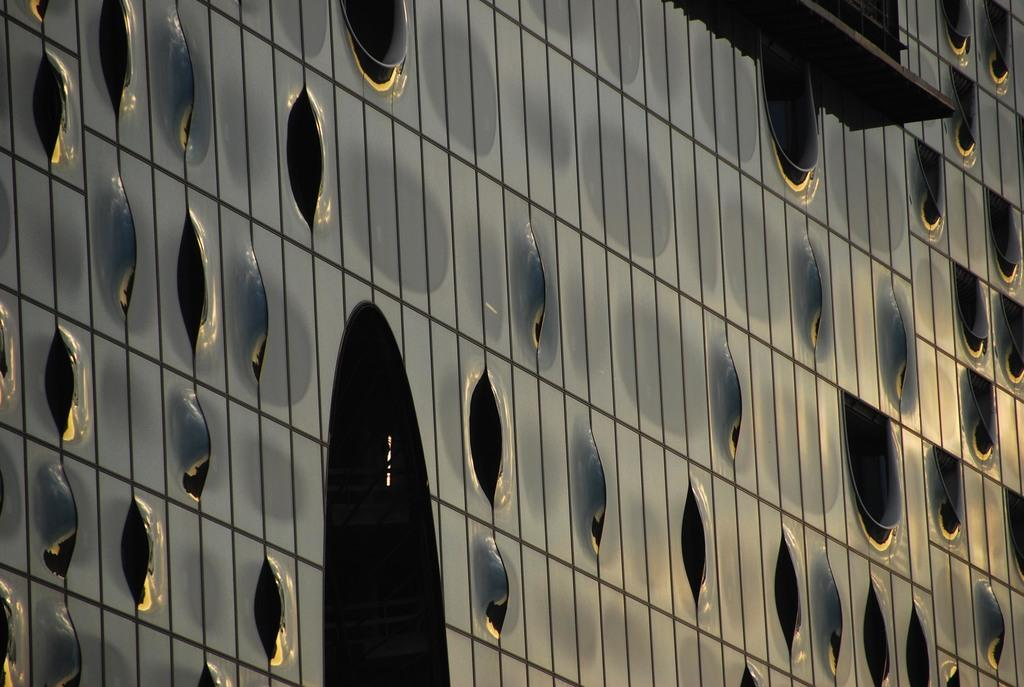What type of view is shown in the image? The image shows an outside view of a building. Can you describe the building in the image? Unfortunately, the provided facts do not give any details about the building's appearance or features. What might be visible in the background of the image? Since the image shows an outside view of a building, it is possible that there are other buildings, trees, or landscapes visible in the background. However, the provided facts do not give any specific details about the background. What type of fuel is being used by the pear in the image? There is no pear or any reference to fuel in the image. 